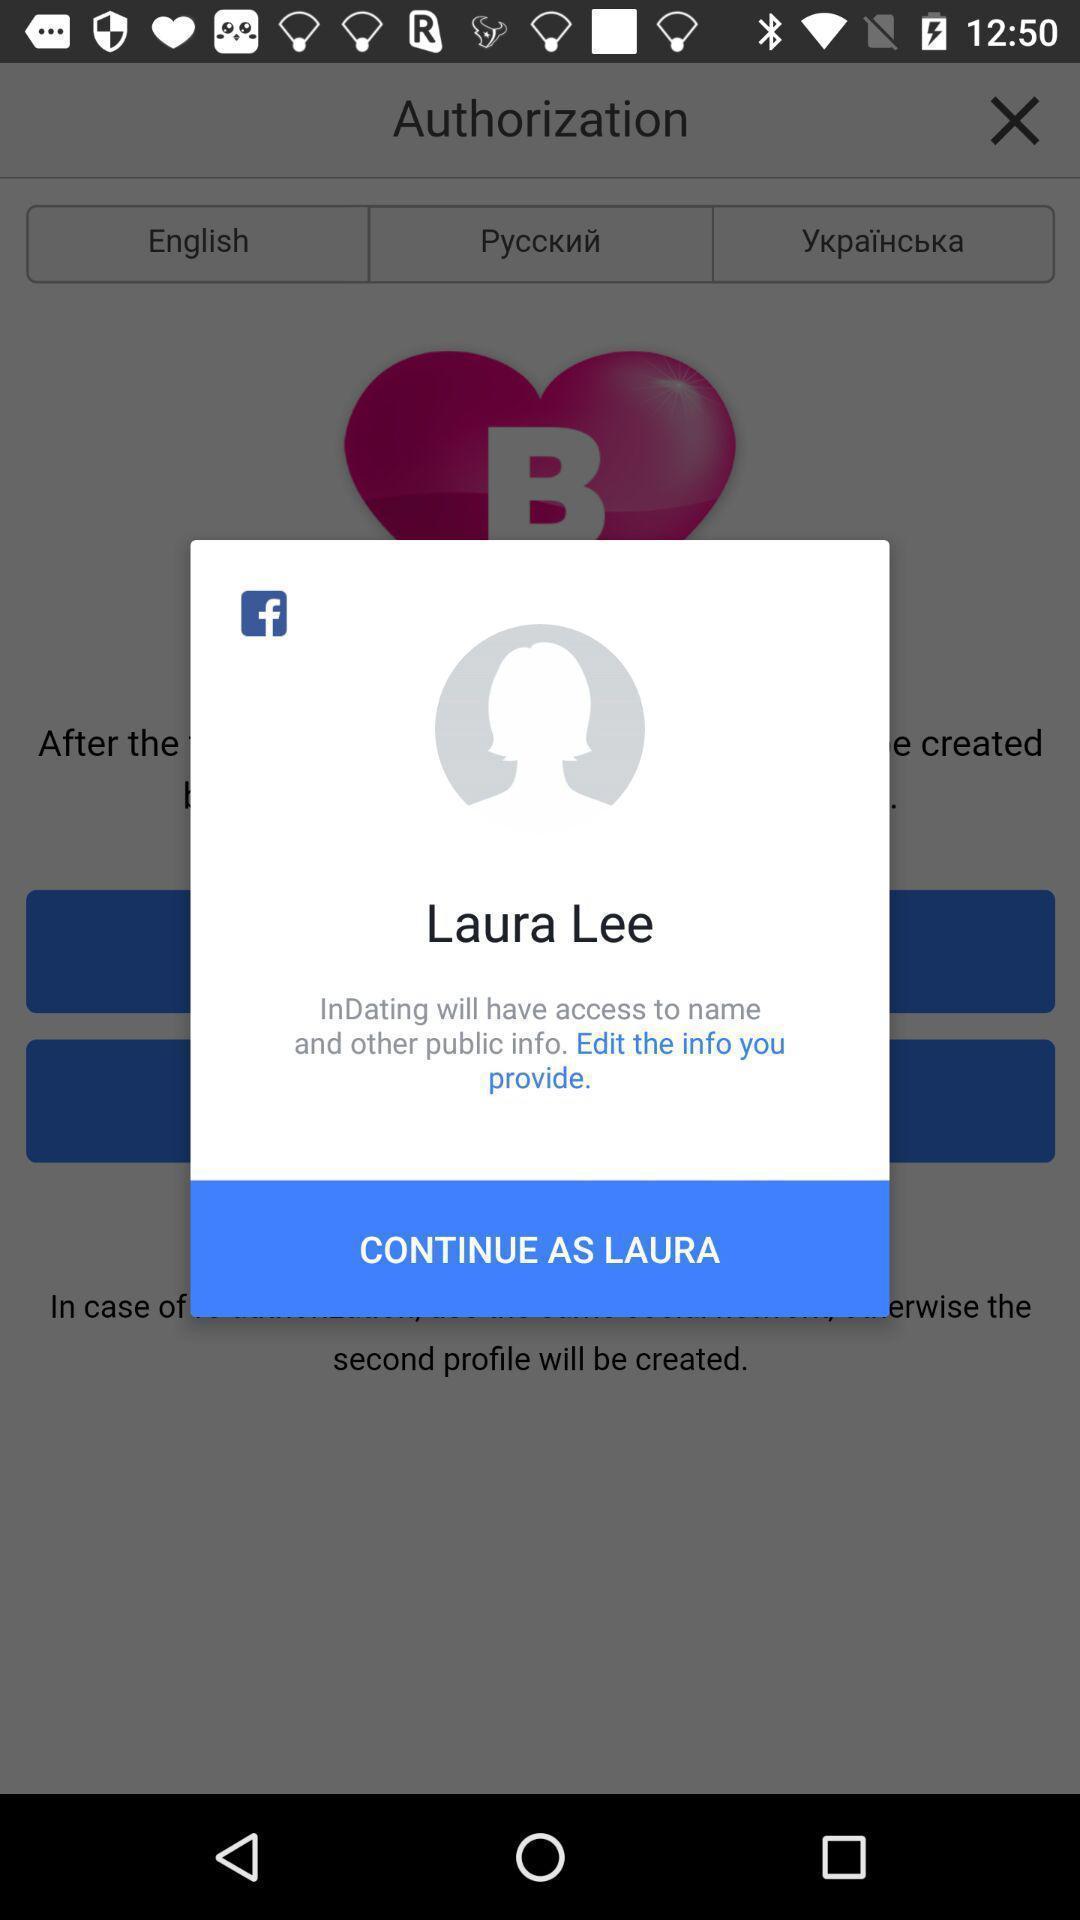Provide a textual representation of this image. Pop-up of edit info profile in a dating app. 